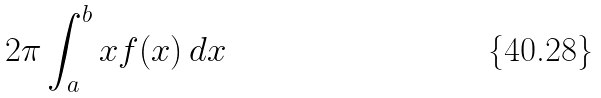<formula> <loc_0><loc_0><loc_500><loc_500>2 \pi \int _ { a } ^ { b } x f ( x ) \, d x</formula> 